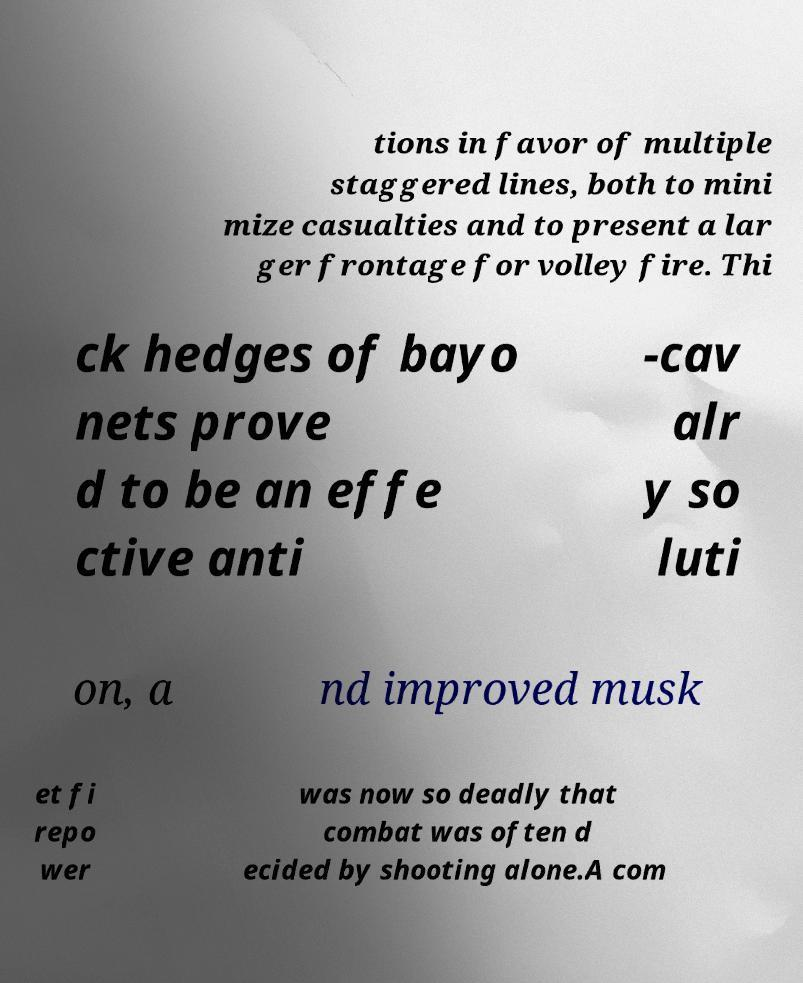There's text embedded in this image that I need extracted. Can you transcribe it verbatim? tions in favor of multiple staggered lines, both to mini mize casualties and to present a lar ger frontage for volley fire. Thi ck hedges of bayo nets prove d to be an effe ctive anti -cav alr y so luti on, a nd improved musk et fi repo wer was now so deadly that combat was often d ecided by shooting alone.A com 